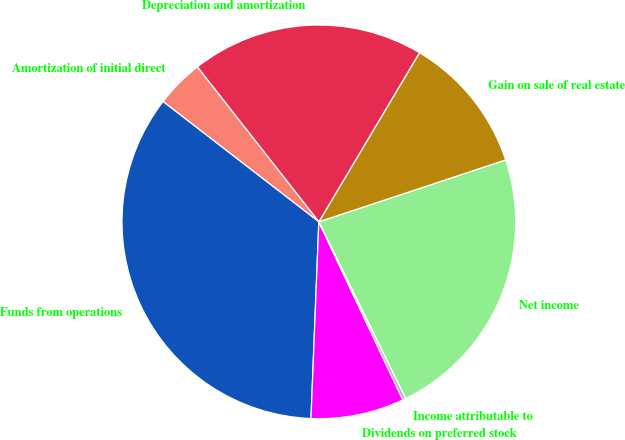Convert chart. <chart><loc_0><loc_0><loc_500><loc_500><pie_chart><fcel>Net income<fcel>Gain on sale of real estate<fcel>Depreciation and amortization<fcel>Amortization of initial direct<fcel>Funds from operations<fcel>Dividends on preferred stock<fcel>Income attributable to<nl><fcel>22.83%<fcel>11.36%<fcel>19.13%<fcel>3.95%<fcel>34.83%<fcel>7.65%<fcel>0.25%<nl></chart> 